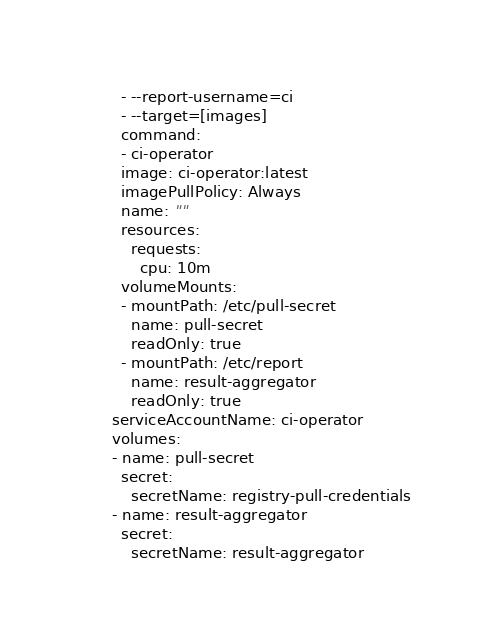Convert code to text. <code><loc_0><loc_0><loc_500><loc_500><_YAML_>        - --report-username=ci
        - --target=[images]
        command:
        - ci-operator
        image: ci-operator:latest
        imagePullPolicy: Always
        name: ""
        resources:
          requests:
            cpu: 10m
        volumeMounts:
        - mountPath: /etc/pull-secret
          name: pull-secret
          readOnly: true
        - mountPath: /etc/report
          name: result-aggregator
          readOnly: true
      serviceAccountName: ci-operator
      volumes:
      - name: pull-secret
        secret:
          secretName: registry-pull-credentials
      - name: result-aggregator
        secret:
          secretName: result-aggregator
</code> 